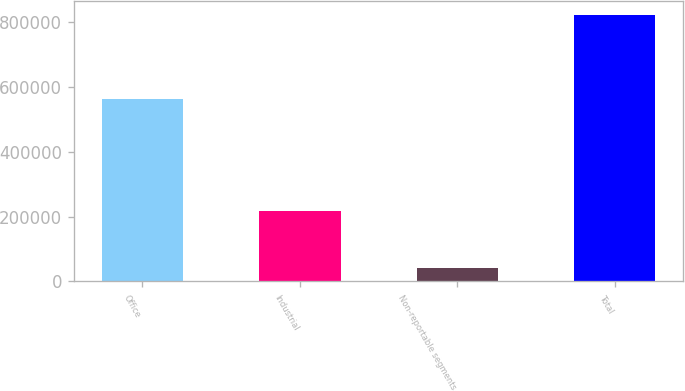<chart> <loc_0><loc_0><loc_500><loc_500><bar_chart><fcel>Office<fcel>Industrial<fcel>Non-reportable segments<fcel>Total<nl><fcel>562277<fcel>218055<fcel>42376<fcel>822708<nl></chart> 